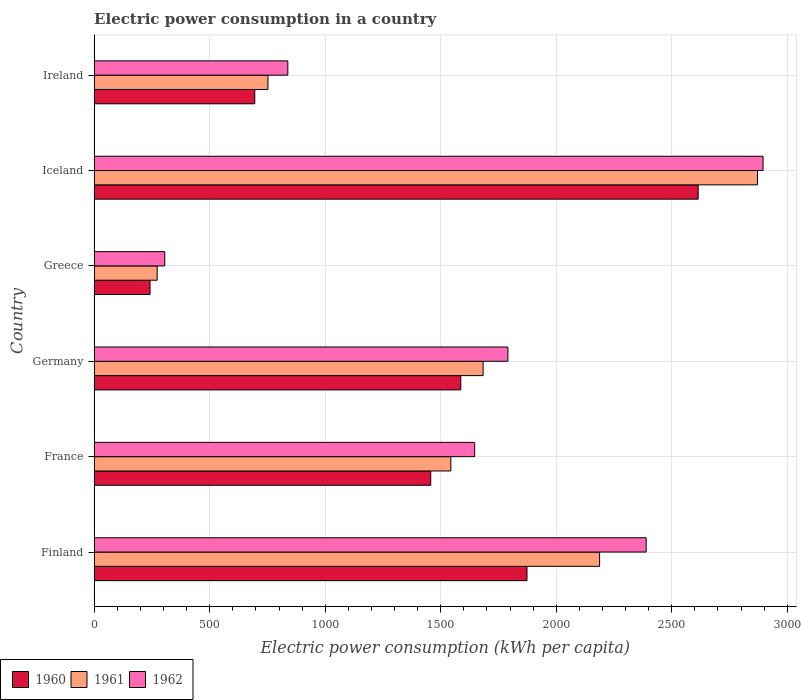How many different coloured bars are there?
Ensure brevity in your answer.  3. How many groups of bars are there?
Offer a terse response. 6. How many bars are there on the 2nd tick from the top?
Give a very brief answer. 3. In how many cases, is the number of bars for a given country not equal to the number of legend labels?
Your answer should be very brief. 0. What is the electric power consumption in in 1961 in Greece?
Ensure brevity in your answer.  272.56. Across all countries, what is the maximum electric power consumption in in 1961?
Keep it short and to the point. 2871.04. Across all countries, what is the minimum electric power consumption in in 1961?
Give a very brief answer. 272.56. In which country was the electric power consumption in in 1961 maximum?
Offer a terse response. Iceland. What is the total electric power consumption in in 1962 in the graph?
Provide a succinct answer. 9865.34. What is the difference between the electric power consumption in in 1962 in Greece and that in Iceland?
Your answer should be compact. -2589.7. What is the difference between the electric power consumption in in 1960 in Greece and the electric power consumption in in 1962 in Finland?
Make the answer very short. -2147.48. What is the average electric power consumption in in 1962 per country?
Your answer should be very brief. 1644.22. What is the difference between the electric power consumption in in 1961 and electric power consumption in in 1962 in Finland?
Offer a terse response. -201.59. What is the ratio of the electric power consumption in in 1960 in France to that in Iceland?
Your answer should be compact. 0.56. Is the difference between the electric power consumption in in 1961 in Germany and Iceland greater than the difference between the electric power consumption in in 1962 in Germany and Iceland?
Make the answer very short. No. What is the difference between the highest and the second highest electric power consumption in in 1962?
Your answer should be compact. 505.88. What is the difference between the highest and the lowest electric power consumption in in 1960?
Keep it short and to the point. 2372.56. Is the sum of the electric power consumption in in 1961 in Greece and Iceland greater than the maximum electric power consumption in in 1962 across all countries?
Your answer should be compact. Yes. What does the 3rd bar from the bottom in Greece represents?
Offer a very short reply. 1962. Is it the case that in every country, the sum of the electric power consumption in in 1961 and electric power consumption in in 1962 is greater than the electric power consumption in in 1960?
Keep it short and to the point. Yes. How many countries are there in the graph?
Give a very brief answer. 6. What is the difference between two consecutive major ticks on the X-axis?
Ensure brevity in your answer.  500. Are the values on the major ticks of X-axis written in scientific E-notation?
Your answer should be very brief. No. Does the graph contain grids?
Provide a succinct answer. Yes. How many legend labels are there?
Offer a very short reply. 3. What is the title of the graph?
Your answer should be very brief. Electric power consumption in a country. Does "1995" appear as one of the legend labels in the graph?
Your answer should be compact. No. What is the label or title of the X-axis?
Give a very brief answer. Electric power consumption (kWh per capita). What is the Electric power consumption (kWh per capita) in 1960 in Finland?
Ensure brevity in your answer.  1873.29. What is the Electric power consumption (kWh per capita) of 1961 in Finland?
Offer a very short reply. 2187.62. What is the Electric power consumption (kWh per capita) of 1962 in Finland?
Keep it short and to the point. 2389.21. What is the Electric power consumption (kWh per capita) in 1960 in France?
Keep it short and to the point. 1456.69. What is the Electric power consumption (kWh per capita) in 1961 in France?
Your response must be concise. 1543.71. What is the Electric power consumption (kWh per capita) in 1962 in France?
Offer a very short reply. 1646.83. What is the Electric power consumption (kWh per capita) of 1960 in Germany?
Your response must be concise. 1586.75. What is the Electric power consumption (kWh per capita) in 1961 in Germany?
Your response must be concise. 1683.41. What is the Electric power consumption (kWh per capita) of 1962 in Germany?
Offer a terse response. 1790.69. What is the Electric power consumption (kWh per capita) of 1960 in Greece?
Make the answer very short. 241.73. What is the Electric power consumption (kWh per capita) of 1961 in Greece?
Your answer should be compact. 272.56. What is the Electric power consumption (kWh per capita) of 1962 in Greece?
Offer a very short reply. 305.39. What is the Electric power consumption (kWh per capita) of 1960 in Iceland?
Provide a short and direct response. 2614.28. What is the Electric power consumption (kWh per capita) of 1961 in Iceland?
Your answer should be compact. 2871.04. What is the Electric power consumption (kWh per capita) of 1962 in Iceland?
Your answer should be very brief. 2895.09. What is the Electric power consumption (kWh per capita) of 1960 in Ireland?
Provide a succinct answer. 695.04. What is the Electric power consumption (kWh per capita) in 1961 in Ireland?
Make the answer very short. 752.02. What is the Electric power consumption (kWh per capita) of 1962 in Ireland?
Provide a succinct answer. 838.14. Across all countries, what is the maximum Electric power consumption (kWh per capita) in 1960?
Your response must be concise. 2614.28. Across all countries, what is the maximum Electric power consumption (kWh per capita) in 1961?
Your response must be concise. 2871.04. Across all countries, what is the maximum Electric power consumption (kWh per capita) of 1962?
Keep it short and to the point. 2895.09. Across all countries, what is the minimum Electric power consumption (kWh per capita) in 1960?
Offer a very short reply. 241.73. Across all countries, what is the minimum Electric power consumption (kWh per capita) in 1961?
Make the answer very short. 272.56. Across all countries, what is the minimum Electric power consumption (kWh per capita) of 1962?
Make the answer very short. 305.39. What is the total Electric power consumption (kWh per capita) in 1960 in the graph?
Keep it short and to the point. 8467.79. What is the total Electric power consumption (kWh per capita) of 1961 in the graph?
Your answer should be very brief. 9310.37. What is the total Electric power consumption (kWh per capita) of 1962 in the graph?
Your answer should be compact. 9865.34. What is the difference between the Electric power consumption (kWh per capita) in 1960 in Finland and that in France?
Provide a short and direct response. 416.6. What is the difference between the Electric power consumption (kWh per capita) in 1961 in Finland and that in France?
Offer a terse response. 643.91. What is the difference between the Electric power consumption (kWh per capita) of 1962 in Finland and that in France?
Provide a short and direct response. 742.38. What is the difference between the Electric power consumption (kWh per capita) in 1960 in Finland and that in Germany?
Provide a succinct answer. 286.54. What is the difference between the Electric power consumption (kWh per capita) of 1961 in Finland and that in Germany?
Offer a very short reply. 504.21. What is the difference between the Electric power consumption (kWh per capita) of 1962 in Finland and that in Germany?
Provide a short and direct response. 598.52. What is the difference between the Electric power consumption (kWh per capita) in 1960 in Finland and that in Greece?
Offer a terse response. 1631.57. What is the difference between the Electric power consumption (kWh per capita) in 1961 in Finland and that in Greece?
Provide a succinct answer. 1915.06. What is the difference between the Electric power consumption (kWh per capita) in 1962 in Finland and that in Greece?
Your answer should be compact. 2083.82. What is the difference between the Electric power consumption (kWh per capita) in 1960 in Finland and that in Iceland?
Your answer should be compact. -740.99. What is the difference between the Electric power consumption (kWh per capita) in 1961 in Finland and that in Iceland?
Ensure brevity in your answer.  -683.42. What is the difference between the Electric power consumption (kWh per capita) of 1962 in Finland and that in Iceland?
Your answer should be very brief. -505.88. What is the difference between the Electric power consumption (kWh per capita) in 1960 in Finland and that in Ireland?
Offer a terse response. 1178.25. What is the difference between the Electric power consumption (kWh per capita) of 1961 in Finland and that in Ireland?
Provide a succinct answer. 1435.61. What is the difference between the Electric power consumption (kWh per capita) in 1962 in Finland and that in Ireland?
Offer a terse response. 1551.07. What is the difference between the Electric power consumption (kWh per capita) of 1960 in France and that in Germany?
Your answer should be compact. -130.06. What is the difference between the Electric power consumption (kWh per capita) in 1961 in France and that in Germany?
Your response must be concise. -139.7. What is the difference between the Electric power consumption (kWh per capita) of 1962 in France and that in Germany?
Your response must be concise. -143.85. What is the difference between the Electric power consumption (kWh per capita) in 1960 in France and that in Greece?
Your answer should be compact. 1214.97. What is the difference between the Electric power consumption (kWh per capita) of 1961 in France and that in Greece?
Make the answer very short. 1271.15. What is the difference between the Electric power consumption (kWh per capita) in 1962 in France and that in Greece?
Provide a succinct answer. 1341.44. What is the difference between the Electric power consumption (kWh per capita) of 1960 in France and that in Iceland?
Ensure brevity in your answer.  -1157.59. What is the difference between the Electric power consumption (kWh per capita) of 1961 in France and that in Iceland?
Your answer should be very brief. -1327.33. What is the difference between the Electric power consumption (kWh per capita) of 1962 in France and that in Iceland?
Offer a terse response. -1248.25. What is the difference between the Electric power consumption (kWh per capita) of 1960 in France and that in Ireland?
Provide a short and direct response. 761.65. What is the difference between the Electric power consumption (kWh per capita) in 1961 in France and that in Ireland?
Provide a short and direct response. 791.69. What is the difference between the Electric power consumption (kWh per capita) in 1962 in France and that in Ireland?
Provide a succinct answer. 808.69. What is the difference between the Electric power consumption (kWh per capita) in 1960 in Germany and that in Greece?
Provide a succinct answer. 1345.02. What is the difference between the Electric power consumption (kWh per capita) in 1961 in Germany and that in Greece?
Your response must be concise. 1410.85. What is the difference between the Electric power consumption (kWh per capita) of 1962 in Germany and that in Greece?
Give a very brief answer. 1485.3. What is the difference between the Electric power consumption (kWh per capita) of 1960 in Germany and that in Iceland?
Offer a very short reply. -1027.53. What is the difference between the Electric power consumption (kWh per capita) in 1961 in Germany and that in Iceland?
Your answer should be very brief. -1187.63. What is the difference between the Electric power consumption (kWh per capita) in 1962 in Germany and that in Iceland?
Your response must be concise. -1104.4. What is the difference between the Electric power consumption (kWh per capita) of 1960 in Germany and that in Ireland?
Your answer should be compact. 891.71. What is the difference between the Electric power consumption (kWh per capita) of 1961 in Germany and that in Ireland?
Your response must be concise. 931.4. What is the difference between the Electric power consumption (kWh per capita) in 1962 in Germany and that in Ireland?
Your response must be concise. 952.55. What is the difference between the Electric power consumption (kWh per capita) in 1960 in Greece and that in Iceland?
Provide a short and direct response. -2372.56. What is the difference between the Electric power consumption (kWh per capita) of 1961 in Greece and that in Iceland?
Offer a very short reply. -2598.48. What is the difference between the Electric power consumption (kWh per capita) in 1962 in Greece and that in Iceland?
Provide a succinct answer. -2589.7. What is the difference between the Electric power consumption (kWh per capita) of 1960 in Greece and that in Ireland?
Ensure brevity in your answer.  -453.32. What is the difference between the Electric power consumption (kWh per capita) of 1961 in Greece and that in Ireland?
Provide a short and direct response. -479.45. What is the difference between the Electric power consumption (kWh per capita) in 1962 in Greece and that in Ireland?
Provide a short and direct response. -532.75. What is the difference between the Electric power consumption (kWh per capita) in 1960 in Iceland and that in Ireland?
Your answer should be very brief. 1919.24. What is the difference between the Electric power consumption (kWh per capita) in 1961 in Iceland and that in Ireland?
Ensure brevity in your answer.  2119.03. What is the difference between the Electric power consumption (kWh per capita) of 1962 in Iceland and that in Ireland?
Your response must be concise. 2056.95. What is the difference between the Electric power consumption (kWh per capita) in 1960 in Finland and the Electric power consumption (kWh per capita) in 1961 in France?
Keep it short and to the point. 329.58. What is the difference between the Electric power consumption (kWh per capita) of 1960 in Finland and the Electric power consumption (kWh per capita) of 1962 in France?
Make the answer very short. 226.46. What is the difference between the Electric power consumption (kWh per capita) of 1961 in Finland and the Electric power consumption (kWh per capita) of 1962 in France?
Provide a short and direct response. 540.79. What is the difference between the Electric power consumption (kWh per capita) in 1960 in Finland and the Electric power consumption (kWh per capita) in 1961 in Germany?
Your answer should be very brief. 189.88. What is the difference between the Electric power consumption (kWh per capita) in 1960 in Finland and the Electric power consumption (kWh per capita) in 1962 in Germany?
Give a very brief answer. 82.61. What is the difference between the Electric power consumption (kWh per capita) in 1961 in Finland and the Electric power consumption (kWh per capita) in 1962 in Germany?
Give a very brief answer. 396.94. What is the difference between the Electric power consumption (kWh per capita) in 1960 in Finland and the Electric power consumption (kWh per capita) in 1961 in Greece?
Offer a very short reply. 1600.73. What is the difference between the Electric power consumption (kWh per capita) of 1960 in Finland and the Electric power consumption (kWh per capita) of 1962 in Greece?
Offer a terse response. 1567.9. What is the difference between the Electric power consumption (kWh per capita) of 1961 in Finland and the Electric power consumption (kWh per capita) of 1962 in Greece?
Your answer should be very brief. 1882.23. What is the difference between the Electric power consumption (kWh per capita) in 1960 in Finland and the Electric power consumption (kWh per capita) in 1961 in Iceland?
Your answer should be very brief. -997.75. What is the difference between the Electric power consumption (kWh per capita) of 1960 in Finland and the Electric power consumption (kWh per capita) of 1962 in Iceland?
Your response must be concise. -1021.79. What is the difference between the Electric power consumption (kWh per capita) in 1961 in Finland and the Electric power consumption (kWh per capita) in 1962 in Iceland?
Your response must be concise. -707.46. What is the difference between the Electric power consumption (kWh per capita) in 1960 in Finland and the Electric power consumption (kWh per capita) in 1961 in Ireland?
Ensure brevity in your answer.  1121.27. What is the difference between the Electric power consumption (kWh per capita) in 1960 in Finland and the Electric power consumption (kWh per capita) in 1962 in Ireland?
Give a very brief answer. 1035.15. What is the difference between the Electric power consumption (kWh per capita) of 1961 in Finland and the Electric power consumption (kWh per capita) of 1962 in Ireland?
Provide a succinct answer. 1349.49. What is the difference between the Electric power consumption (kWh per capita) in 1960 in France and the Electric power consumption (kWh per capita) in 1961 in Germany?
Keep it short and to the point. -226.72. What is the difference between the Electric power consumption (kWh per capita) of 1960 in France and the Electric power consumption (kWh per capita) of 1962 in Germany?
Your answer should be very brief. -333.99. What is the difference between the Electric power consumption (kWh per capita) of 1961 in France and the Electric power consumption (kWh per capita) of 1962 in Germany?
Ensure brevity in your answer.  -246.98. What is the difference between the Electric power consumption (kWh per capita) in 1960 in France and the Electric power consumption (kWh per capita) in 1961 in Greece?
Your answer should be compact. 1184.13. What is the difference between the Electric power consumption (kWh per capita) of 1960 in France and the Electric power consumption (kWh per capita) of 1962 in Greece?
Ensure brevity in your answer.  1151.3. What is the difference between the Electric power consumption (kWh per capita) in 1961 in France and the Electric power consumption (kWh per capita) in 1962 in Greece?
Provide a short and direct response. 1238.32. What is the difference between the Electric power consumption (kWh per capita) in 1960 in France and the Electric power consumption (kWh per capita) in 1961 in Iceland?
Your response must be concise. -1414.35. What is the difference between the Electric power consumption (kWh per capita) of 1960 in France and the Electric power consumption (kWh per capita) of 1962 in Iceland?
Give a very brief answer. -1438.39. What is the difference between the Electric power consumption (kWh per capita) in 1961 in France and the Electric power consumption (kWh per capita) in 1962 in Iceland?
Offer a terse response. -1351.37. What is the difference between the Electric power consumption (kWh per capita) of 1960 in France and the Electric power consumption (kWh per capita) of 1961 in Ireland?
Your answer should be compact. 704.68. What is the difference between the Electric power consumption (kWh per capita) in 1960 in France and the Electric power consumption (kWh per capita) in 1962 in Ireland?
Provide a short and direct response. 618.56. What is the difference between the Electric power consumption (kWh per capita) in 1961 in France and the Electric power consumption (kWh per capita) in 1962 in Ireland?
Provide a short and direct response. 705.57. What is the difference between the Electric power consumption (kWh per capita) of 1960 in Germany and the Electric power consumption (kWh per capita) of 1961 in Greece?
Provide a short and direct response. 1314.19. What is the difference between the Electric power consumption (kWh per capita) of 1960 in Germany and the Electric power consumption (kWh per capita) of 1962 in Greece?
Your response must be concise. 1281.36. What is the difference between the Electric power consumption (kWh per capita) of 1961 in Germany and the Electric power consumption (kWh per capita) of 1962 in Greece?
Ensure brevity in your answer.  1378.03. What is the difference between the Electric power consumption (kWh per capita) in 1960 in Germany and the Electric power consumption (kWh per capita) in 1961 in Iceland?
Your answer should be very brief. -1284.29. What is the difference between the Electric power consumption (kWh per capita) in 1960 in Germany and the Electric power consumption (kWh per capita) in 1962 in Iceland?
Ensure brevity in your answer.  -1308.34. What is the difference between the Electric power consumption (kWh per capita) of 1961 in Germany and the Electric power consumption (kWh per capita) of 1962 in Iceland?
Offer a terse response. -1211.67. What is the difference between the Electric power consumption (kWh per capita) in 1960 in Germany and the Electric power consumption (kWh per capita) in 1961 in Ireland?
Ensure brevity in your answer.  834.73. What is the difference between the Electric power consumption (kWh per capita) in 1960 in Germany and the Electric power consumption (kWh per capita) in 1962 in Ireland?
Make the answer very short. 748.61. What is the difference between the Electric power consumption (kWh per capita) in 1961 in Germany and the Electric power consumption (kWh per capita) in 1962 in Ireland?
Provide a succinct answer. 845.28. What is the difference between the Electric power consumption (kWh per capita) in 1960 in Greece and the Electric power consumption (kWh per capita) in 1961 in Iceland?
Keep it short and to the point. -2629.32. What is the difference between the Electric power consumption (kWh per capita) of 1960 in Greece and the Electric power consumption (kWh per capita) of 1962 in Iceland?
Provide a succinct answer. -2653.36. What is the difference between the Electric power consumption (kWh per capita) of 1961 in Greece and the Electric power consumption (kWh per capita) of 1962 in Iceland?
Keep it short and to the point. -2622.52. What is the difference between the Electric power consumption (kWh per capita) in 1960 in Greece and the Electric power consumption (kWh per capita) in 1961 in Ireland?
Keep it short and to the point. -510.29. What is the difference between the Electric power consumption (kWh per capita) of 1960 in Greece and the Electric power consumption (kWh per capita) of 1962 in Ireland?
Offer a very short reply. -596.41. What is the difference between the Electric power consumption (kWh per capita) of 1961 in Greece and the Electric power consumption (kWh per capita) of 1962 in Ireland?
Your answer should be very brief. -565.57. What is the difference between the Electric power consumption (kWh per capita) of 1960 in Iceland and the Electric power consumption (kWh per capita) of 1961 in Ireland?
Ensure brevity in your answer.  1862.26. What is the difference between the Electric power consumption (kWh per capita) in 1960 in Iceland and the Electric power consumption (kWh per capita) in 1962 in Ireland?
Offer a terse response. 1776.14. What is the difference between the Electric power consumption (kWh per capita) in 1961 in Iceland and the Electric power consumption (kWh per capita) in 1962 in Ireland?
Offer a very short reply. 2032.91. What is the average Electric power consumption (kWh per capita) of 1960 per country?
Provide a succinct answer. 1411.3. What is the average Electric power consumption (kWh per capita) in 1961 per country?
Your answer should be very brief. 1551.73. What is the average Electric power consumption (kWh per capita) of 1962 per country?
Provide a succinct answer. 1644.22. What is the difference between the Electric power consumption (kWh per capita) of 1960 and Electric power consumption (kWh per capita) of 1961 in Finland?
Provide a short and direct response. -314.33. What is the difference between the Electric power consumption (kWh per capita) in 1960 and Electric power consumption (kWh per capita) in 1962 in Finland?
Keep it short and to the point. -515.92. What is the difference between the Electric power consumption (kWh per capita) in 1961 and Electric power consumption (kWh per capita) in 1962 in Finland?
Offer a terse response. -201.59. What is the difference between the Electric power consumption (kWh per capita) of 1960 and Electric power consumption (kWh per capita) of 1961 in France?
Give a very brief answer. -87.02. What is the difference between the Electric power consumption (kWh per capita) in 1960 and Electric power consumption (kWh per capita) in 1962 in France?
Give a very brief answer. -190.14. What is the difference between the Electric power consumption (kWh per capita) of 1961 and Electric power consumption (kWh per capita) of 1962 in France?
Your response must be concise. -103.12. What is the difference between the Electric power consumption (kWh per capita) of 1960 and Electric power consumption (kWh per capita) of 1961 in Germany?
Your response must be concise. -96.67. What is the difference between the Electric power consumption (kWh per capita) of 1960 and Electric power consumption (kWh per capita) of 1962 in Germany?
Offer a very short reply. -203.94. What is the difference between the Electric power consumption (kWh per capita) of 1961 and Electric power consumption (kWh per capita) of 1962 in Germany?
Your response must be concise. -107.27. What is the difference between the Electric power consumption (kWh per capita) of 1960 and Electric power consumption (kWh per capita) of 1961 in Greece?
Provide a succinct answer. -30.84. What is the difference between the Electric power consumption (kWh per capita) in 1960 and Electric power consumption (kWh per capita) in 1962 in Greece?
Provide a short and direct response. -63.66. What is the difference between the Electric power consumption (kWh per capita) in 1961 and Electric power consumption (kWh per capita) in 1962 in Greece?
Provide a succinct answer. -32.83. What is the difference between the Electric power consumption (kWh per capita) of 1960 and Electric power consumption (kWh per capita) of 1961 in Iceland?
Your answer should be very brief. -256.76. What is the difference between the Electric power consumption (kWh per capita) in 1960 and Electric power consumption (kWh per capita) in 1962 in Iceland?
Give a very brief answer. -280.8. What is the difference between the Electric power consumption (kWh per capita) of 1961 and Electric power consumption (kWh per capita) of 1962 in Iceland?
Keep it short and to the point. -24.04. What is the difference between the Electric power consumption (kWh per capita) in 1960 and Electric power consumption (kWh per capita) in 1961 in Ireland?
Provide a short and direct response. -56.97. What is the difference between the Electric power consumption (kWh per capita) of 1960 and Electric power consumption (kWh per capita) of 1962 in Ireland?
Ensure brevity in your answer.  -143.09. What is the difference between the Electric power consumption (kWh per capita) of 1961 and Electric power consumption (kWh per capita) of 1962 in Ireland?
Give a very brief answer. -86.12. What is the ratio of the Electric power consumption (kWh per capita) in 1960 in Finland to that in France?
Give a very brief answer. 1.29. What is the ratio of the Electric power consumption (kWh per capita) of 1961 in Finland to that in France?
Make the answer very short. 1.42. What is the ratio of the Electric power consumption (kWh per capita) in 1962 in Finland to that in France?
Your response must be concise. 1.45. What is the ratio of the Electric power consumption (kWh per capita) in 1960 in Finland to that in Germany?
Provide a short and direct response. 1.18. What is the ratio of the Electric power consumption (kWh per capita) in 1961 in Finland to that in Germany?
Offer a very short reply. 1.3. What is the ratio of the Electric power consumption (kWh per capita) of 1962 in Finland to that in Germany?
Your answer should be compact. 1.33. What is the ratio of the Electric power consumption (kWh per capita) in 1960 in Finland to that in Greece?
Your answer should be very brief. 7.75. What is the ratio of the Electric power consumption (kWh per capita) of 1961 in Finland to that in Greece?
Make the answer very short. 8.03. What is the ratio of the Electric power consumption (kWh per capita) of 1962 in Finland to that in Greece?
Offer a very short reply. 7.82. What is the ratio of the Electric power consumption (kWh per capita) of 1960 in Finland to that in Iceland?
Your answer should be very brief. 0.72. What is the ratio of the Electric power consumption (kWh per capita) in 1961 in Finland to that in Iceland?
Make the answer very short. 0.76. What is the ratio of the Electric power consumption (kWh per capita) of 1962 in Finland to that in Iceland?
Your answer should be compact. 0.83. What is the ratio of the Electric power consumption (kWh per capita) of 1960 in Finland to that in Ireland?
Your response must be concise. 2.7. What is the ratio of the Electric power consumption (kWh per capita) of 1961 in Finland to that in Ireland?
Offer a very short reply. 2.91. What is the ratio of the Electric power consumption (kWh per capita) of 1962 in Finland to that in Ireland?
Provide a succinct answer. 2.85. What is the ratio of the Electric power consumption (kWh per capita) of 1960 in France to that in Germany?
Make the answer very short. 0.92. What is the ratio of the Electric power consumption (kWh per capita) in 1961 in France to that in Germany?
Provide a succinct answer. 0.92. What is the ratio of the Electric power consumption (kWh per capita) in 1962 in France to that in Germany?
Ensure brevity in your answer.  0.92. What is the ratio of the Electric power consumption (kWh per capita) of 1960 in France to that in Greece?
Give a very brief answer. 6.03. What is the ratio of the Electric power consumption (kWh per capita) of 1961 in France to that in Greece?
Your response must be concise. 5.66. What is the ratio of the Electric power consumption (kWh per capita) of 1962 in France to that in Greece?
Your response must be concise. 5.39. What is the ratio of the Electric power consumption (kWh per capita) of 1960 in France to that in Iceland?
Offer a very short reply. 0.56. What is the ratio of the Electric power consumption (kWh per capita) in 1961 in France to that in Iceland?
Ensure brevity in your answer.  0.54. What is the ratio of the Electric power consumption (kWh per capita) of 1962 in France to that in Iceland?
Provide a short and direct response. 0.57. What is the ratio of the Electric power consumption (kWh per capita) in 1960 in France to that in Ireland?
Keep it short and to the point. 2.1. What is the ratio of the Electric power consumption (kWh per capita) of 1961 in France to that in Ireland?
Keep it short and to the point. 2.05. What is the ratio of the Electric power consumption (kWh per capita) in 1962 in France to that in Ireland?
Offer a very short reply. 1.96. What is the ratio of the Electric power consumption (kWh per capita) in 1960 in Germany to that in Greece?
Keep it short and to the point. 6.56. What is the ratio of the Electric power consumption (kWh per capita) of 1961 in Germany to that in Greece?
Your response must be concise. 6.18. What is the ratio of the Electric power consumption (kWh per capita) of 1962 in Germany to that in Greece?
Your answer should be very brief. 5.86. What is the ratio of the Electric power consumption (kWh per capita) in 1960 in Germany to that in Iceland?
Make the answer very short. 0.61. What is the ratio of the Electric power consumption (kWh per capita) in 1961 in Germany to that in Iceland?
Offer a terse response. 0.59. What is the ratio of the Electric power consumption (kWh per capita) of 1962 in Germany to that in Iceland?
Keep it short and to the point. 0.62. What is the ratio of the Electric power consumption (kWh per capita) in 1960 in Germany to that in Ireland?
Ensure brevity in your answer.  2.28. What is the ratio of the Electric power consumption (kWh per capita) of 1961 in Germany to that in Ireland?
Provide a succinct answer. 2.24. What is the ratio of the Electric power consumption (kWh per capita) of 1962 in Germany to that in Ireland?
Offer a very short reply. 2.14. What is the ratio of the Electric power consumption (kWh per capita) of 1960 in Greece to that in Iceland?
Your response must be concise. 0.09. What is the ratio of the Electric power consumption (kWh per capita) in 1961 in Greece to that in Iceland?
Keep it short and to the point. 0.09. What is the ratio of the Electric power consumption (kWh per capita) of 1962 in Greece to that in Iceland?
Your answer should be very brief. 0.11. What is the ratio of the Electric power consumption (kWh per capita) of 1960 in Greece to that in Ireland?
Ensure brevity in your answer.  0.35. What is the ratio of the Electric power consumption (kWh per capita) in 1961 in Greece to that in Ireland?
Your answer should be very brief. 0.36. What is the ratio of the Electric power consumption (kWh per capita) in 1962 in Greece to that in Ireland?
Give a very brief answer. 0.36. What is the ratio of the Electric power consumption (kWh per capita) of 1960 in Iceland to that in Ireland?
Offer a very short reply. 3.76. What is the ratio of the Electric power consumption (kWh per capita) of 1961 in Iceland to that in Ireland?
Provide a succinct answer. 3.82. What is the ratio of the Electric power consumption (kWh per capita) of 1962 in Iceland to that in Ireland?
Provide a short and direct response. 3.45. What is the difference between the highest and the second highest Electric power consumption (kWh per capita) in 1960?
Ensure brevity in your answer.  740.99. What is the difference between the highest and the second highest Electric power consumption (kWh per capita) in 1961?
Your answer should be very brief. 683.42. What is the difference between the highest and the second highest Electric power consumption (kWh per capita) in 1962?
Offer a very short reply. 505.88. What is the difference between the highest and the lowest Electric power consumption (kWh per capita) in 1960?
Offer a very short reply. 2372.56. What is the difference between the highest and the lowest Electric power consumption (kWh per capita) in 1961?
Keep it short and to the point. 2598.48. What is the difference between the highest and the lowest Electric power consumption (kWh per capita) in 1962?
Provide a short and direct response. 2589.7. 